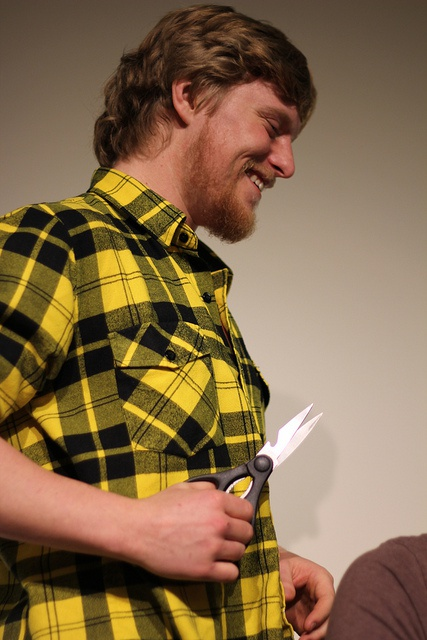Describe the objects in this image and their specific colors. I can see people in maroon, black, and olive tones and scissors in maroon, white, gray, black, and darkgray tones in this image. 